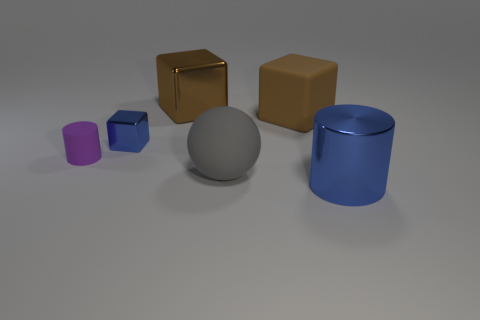Subtract all brown spheres. How many brown blocks are left? 2 Subtract all small metal blocks. How many blocks are left? 2 Subtract 1 blocks. How many blocks are left? 2 Add 4 large brown shiny objects. How many objects exist? 10 Subtract all cyan cubes. Subtract all green cylinders. How many cubes are left? 3 Subtract all cylinders. How many objects are left? 4 Add 3 blue metal blocks. How many blue metal blocks exist? 4 Subtract 0 green spheres. How many objects are left? 6 Subtract all yellow cubes. Subtract all small purple cylinders. How many objects are left? 5 Add 2 small blocks. How many small blocks are left? 3 